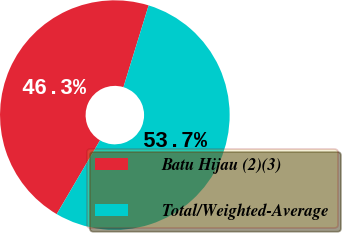Convert chart. <chart><loc_0><loc_0><loc_500><loc_500><pie_chart><fcel>Batu Hijau (2)(3)<fcel>Total/Weighted-Average<nl><fcel>46.31%<fcel>53.69%<nl></chart> 